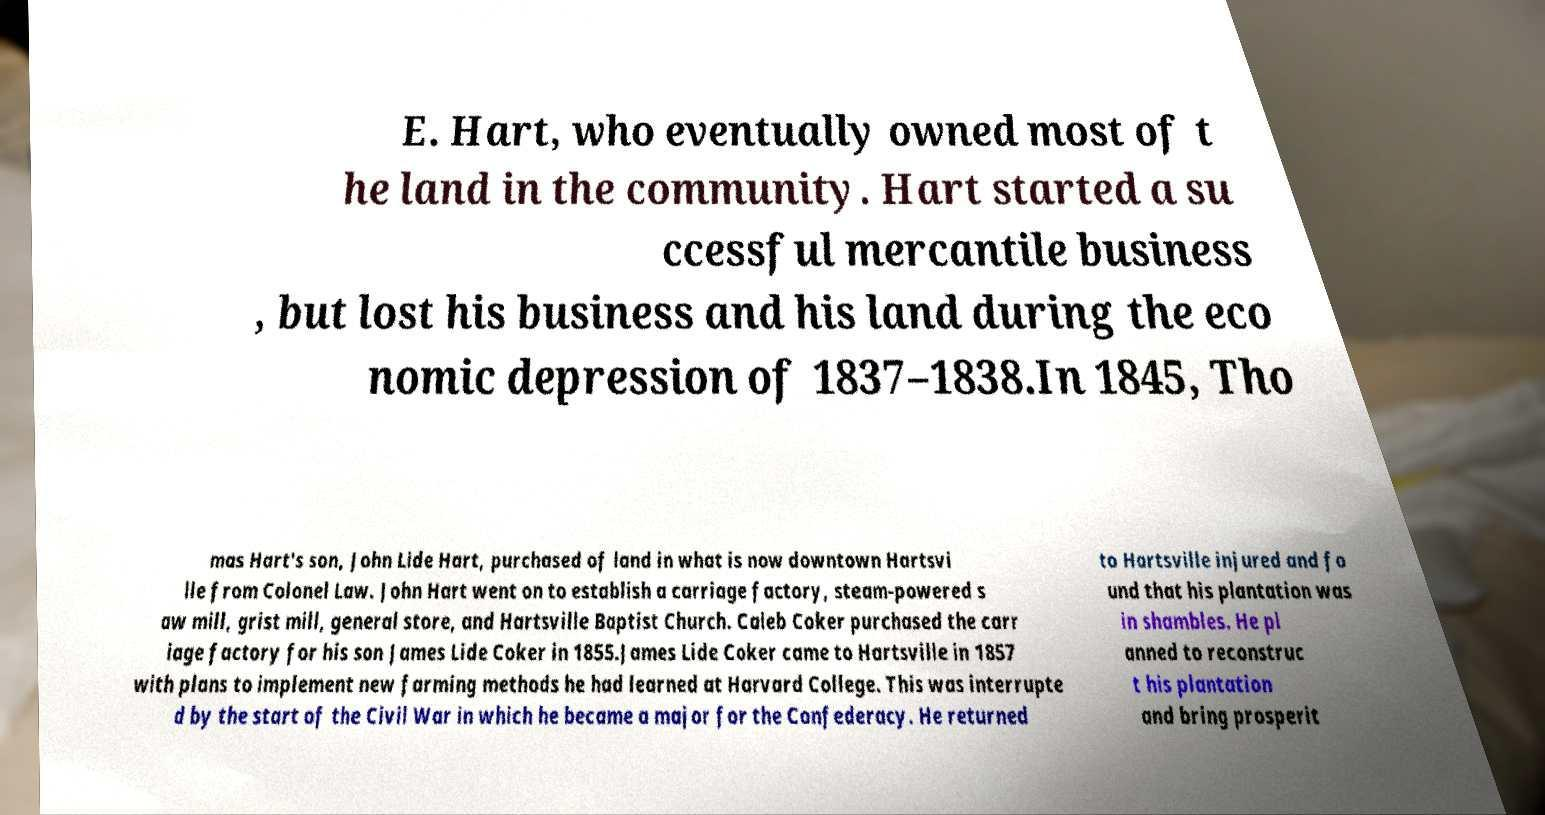Could you assist in decoding the text presented in this image and type it out clearly? E. Hart, who eventually owned most of t he land in the community. Hart started a su ccessful mercantile business , but lost his business and his land during the eco nomic depression of 1837–1838.In 1845, Tho mas Hart's son, John Lide Hart, purchased of land in what is now downtown Hartsvi lle from Colonel Law. John Hart went on to establish a carriage factory, steam-powered s aw mill, grist mill, general store, and Hartsville Baptist Church. Caleb Coker purchased the carr iage factory for his son James Lide Coker in 1855.James Lide Coker came to Hartsville in 1857 with plans to implement new farming methods he had learned at Harvard College. This was interrupte d by the start of the Civil War in which he became a major for the Confederacy. He returned to Hartsville injured and fo und that his plantation was in shambles. He pl anned to reconstruc t his plantation and bring prosperit 